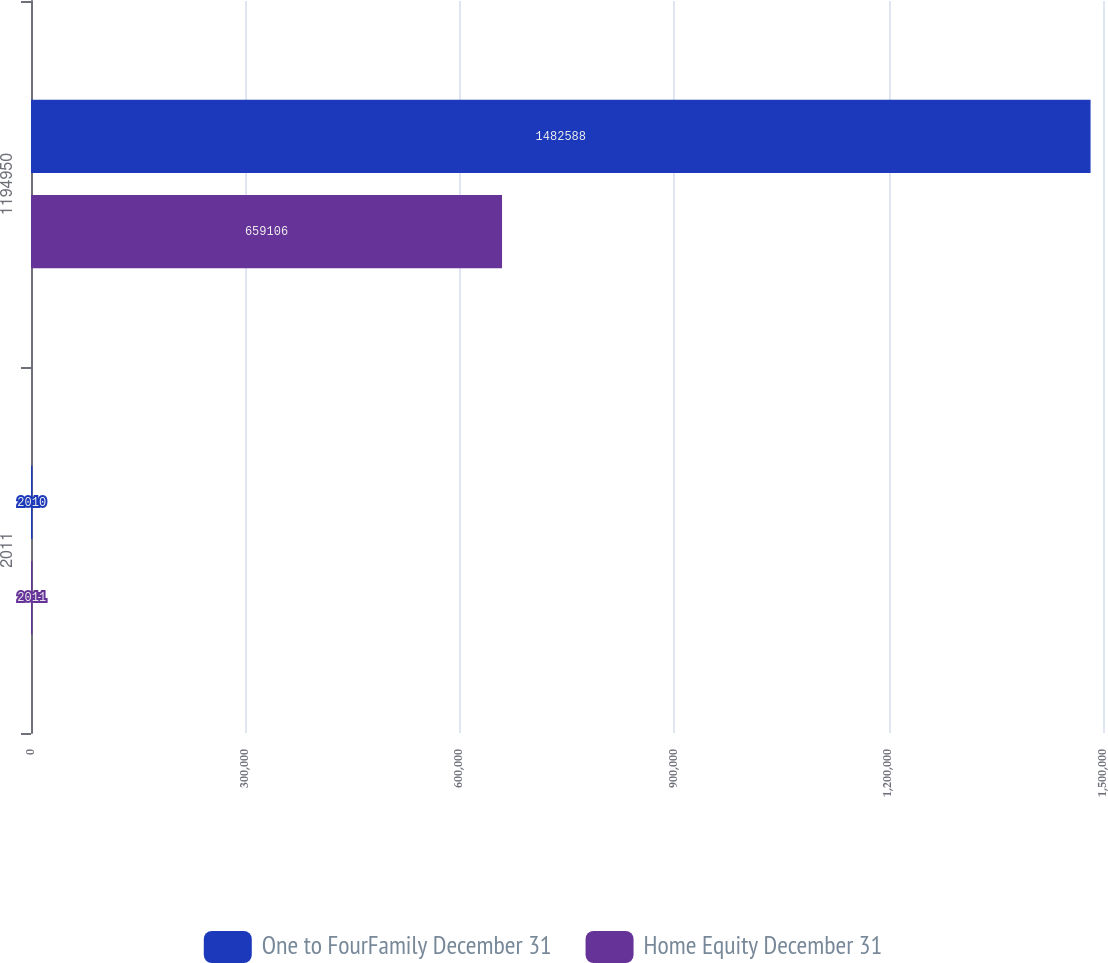Convert chart. <chart><loc_0><loc_0><loc_500><loc_500><stacked_bar_chart><ecel><fcel>2011<fcel>1194950<nl><fcel>One to FourFamily December 31<fcel>2010<fcel>1.48259e+06<nl><fcel>Home Equity December 31<fcel>2011<fcel>659106<nl></chart> 